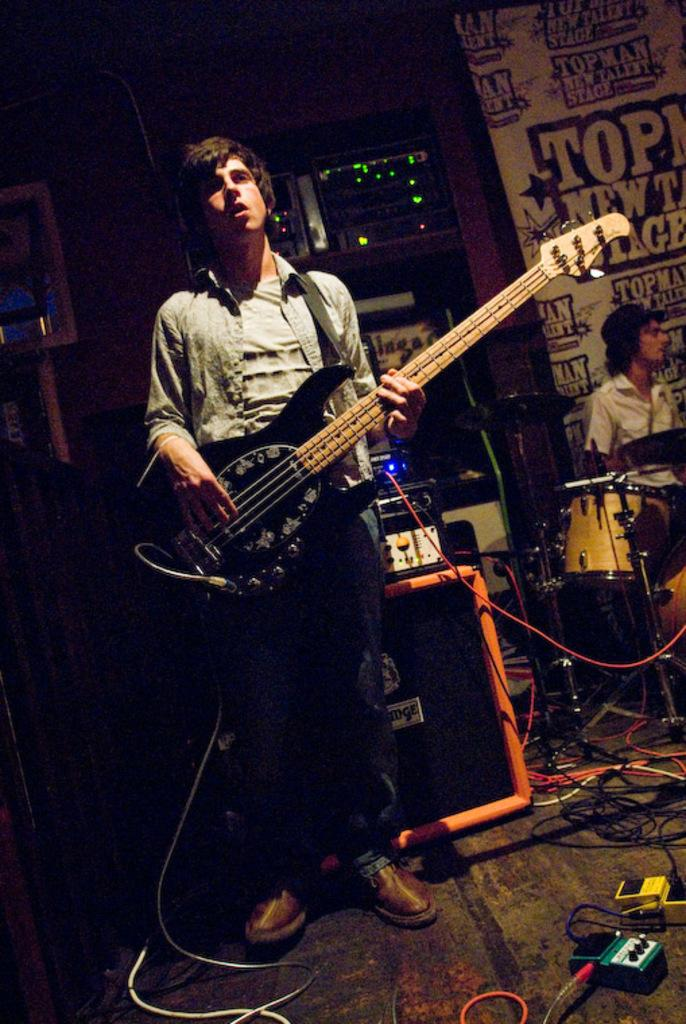What is the main subject of the image? There is a person in the image. What is the person doing in the image? The person is standing in the image. What object is the person holding in the image? The person is holding a guitar in his hand. What type of tooth is visible in the image? There is no tooth visible in the image; it features a person holding a guitar. 